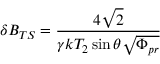<formula> <loc_0><loc_0><loc_500><loc_500>\delta B _ { T S } = \frac { 4 \sqrt { 2 } } { \gamma k T _ { 2 } \sin \theta \sqrt { \Phi _ { p r } } }</formula> 